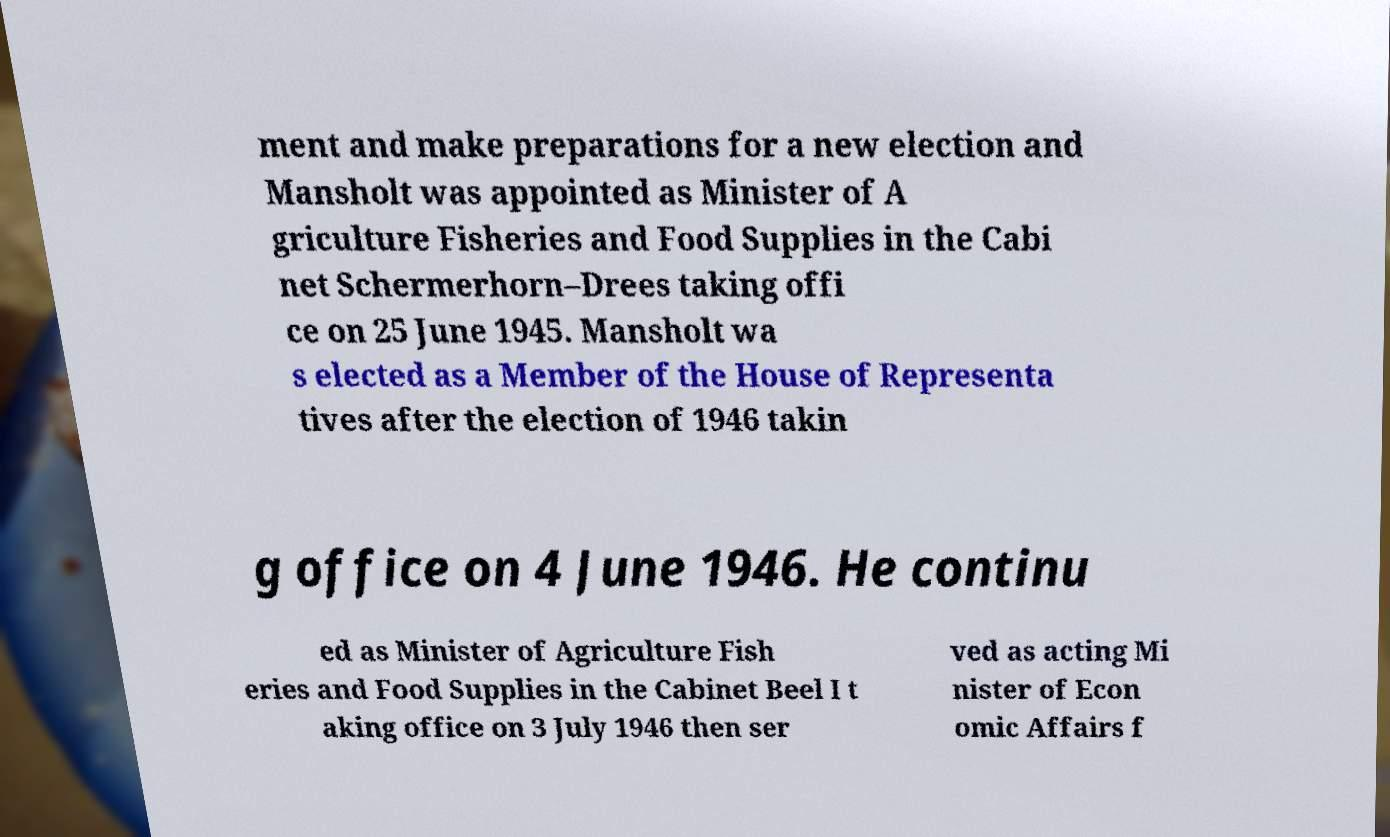What messages or text are displayed in this image? I need them in a readable, typed format. ment and make preparations for a new election and Mansholt was appointed as Minister of A griculture Fisheries and Food Supplies in the Cabi net Schermerhorn–Drees taking offi ce on 25 June 1945. Mansholt wa s elected as a Member of the House of Representa tives after the election of 1946 takin g office on 4 June 1946. He continu ed as Minister of Agriculture Fish eries and Food Supplies in the Cabinet Beel I t aking office on 3 July 1946 then ser ved as acting Mi nister of Econ omic Affairs f 